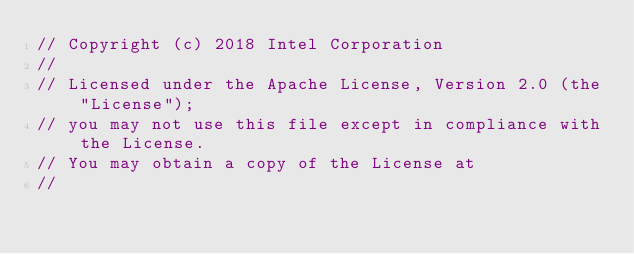<code> <loc_0><loc_0><loc_500><loc_500><_C++_>// Copyright (c) 2018 Intel Corporation
//
// Licensed under the Apache License, Version 2.0 (the "License");
// you may not use this file except in compliance with the License.
// You may obtain a copy of the License at
//</code> 